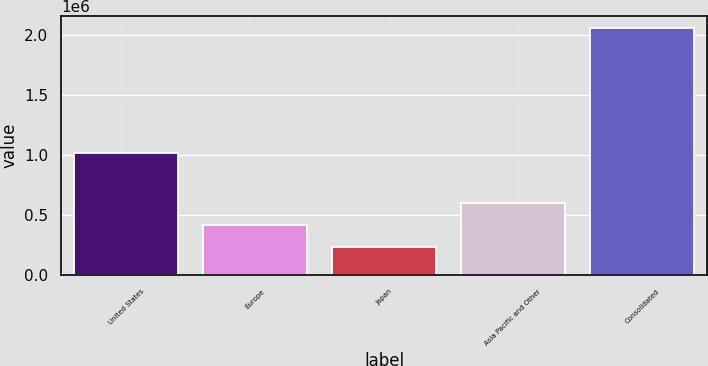<chart> <loc_0><loc_0><loc_500><loc_500><bar_chart><fcel>United States<fcel>Europe<fcel>Japan<fcel>Asia Pacific and Other<fcel>Consolidated<nl><fcel>1.02065e+06<fcel>420476<fcel>238588<fcel>602365<fcel>2.05747e+06<nl></chart> 